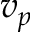Convert formula to latex. <formula><loc_0><loc_0><loc_500><loc_500>v _ { p }</formula> 